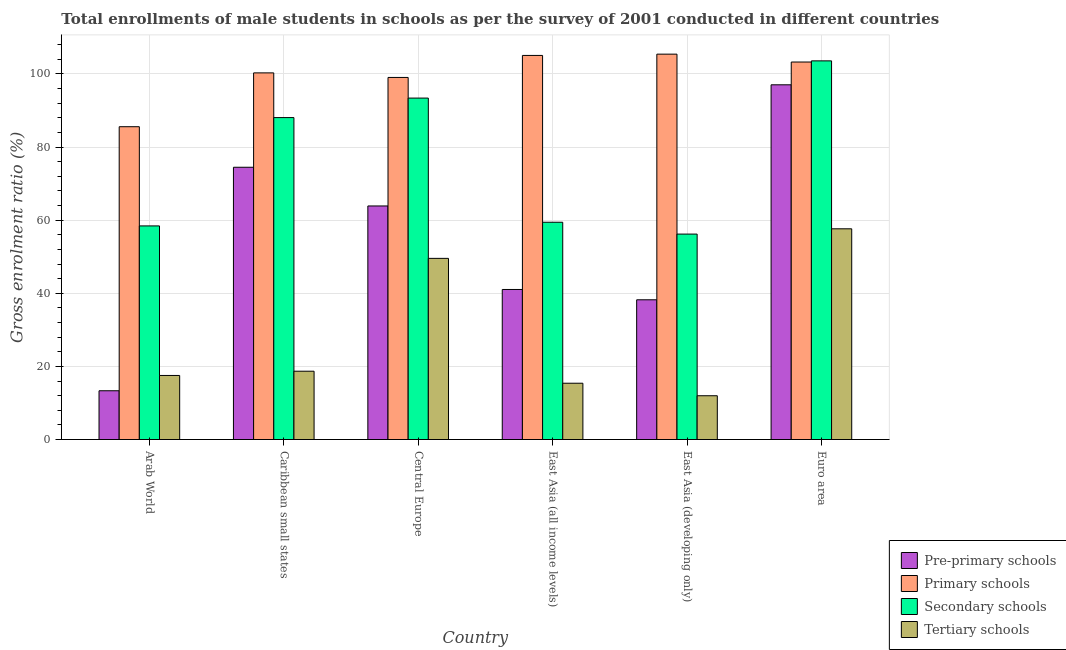How many groups of bars are there?
Offer a terse response. 6. Are the number of bars per tick equal to the number of legend labels?
Make the answer very short. Yes. Are the number of bars on each tick of the X-axis equal?
Provide a short and direct response. Yes. How many bars are there on the 5th tick from the left?
Give a very brief answer. 4. What is the label of the 1st group of bars from the left?
Make the answer very short. Arab World. In how many cases, is the number of bars for a given country not equal to the number of legend labels?
Offer a terse response. 0. What is the gross enrolment ratio(male) in tertiary schools in Caribbean small states?
Keep it short and to the point. 18.68. Across all countries, what is the maximum gross enrolment ratio(male) in secondary schools?
Make the answer very short. 103.56. Across all countries, what is the minimum gross enrolment ratio(male) in pre-primary schools?
Offer a very short reply. 13.34. In which country was the gross enrolment ratio(male) in pre-primary schools minimum?
Offer a terse response. Arab World. What is the total gross enrolment ratio(male) in primary schools in the graph?
Provide a succinct answer. 598.53. What is the difference between the gross enrolment ratio(male) in tertiary schools in Caribbean small states and that in East Asia (developing only)?
Ensure brevity in your answer.  6.71. What is the difference between the gross enrolment ratio(male) in secondary schools in Arab World and the gross enrolment ratio(male) in primary schools in Caribbean small states?
Keep it short and to the point. -41.85. What is the average gross enrolment ratio(male) in pre-primary schools per country?
Your answer should be compact. 54.65. What is the difference between the gross enrolment ratio(male) in secondary schools and gross enrolment ratio(male) in pre-primary schools in East Asia (all income levels)?
Offer a terse response. 18.39. In how many countries, is the gross enrolment ratio(male) in pre-primary schools greater than 76 %?
Provide a succinct answer. 1. What is the ratio of the gross enrolment ratio(male) in tertiary schools in Caribbean small states to that in East Asia (all income levels)?
Keep it short and to the point. 1.21. Is the difference between the gross enrolment ratio(male) in pre-primary schools in Central Europe and East Asia (all income levels) greater than the difference between the gross enrolment ratio(male) in secondary schools in Central Europe and East Asia (all income levels)?
Make the answer very short. No. What is the difference between the highest and the second highest gross enrolment ratio(male) in primary schools?
Provide a short and direct response. 0.35. What is the difference between the highest and the lowest gross enrolment ratio(male) in secondary schools?
Offer a very short reply. 47.37. Is the sum of the gross enrolment ratio(male) in pre-primary schools in Arab World and East Asia (all income levels) greater than the maximum gross enrolment ratio(male) in tertiary schools across all countries?
Your response must be concise. No. Is it the case that in every country, the sum of the gross enrolment ratio(male) in secondary schools and gross enrolment ratio(male) in tertiary schools is greater than the sum of gross enrolment ratio(male) in pre-primary schools and gross enrolment ratio(male) in primary schools?
Offer a terse response. No. What does the 2nd bar from the left in Arab World represents?
Ensure brevity in your answer.  Primary schools. What does the 3rd bar from the right in East Asia (all income levels) represents?
Your answer should be very brief. Primary schools. How many bars are there?
Ensure brevity in your answer.  24. What is the difference between two consecutive major ticks on the Y-axis?
Your answer should be very brief. 20. Does the graph contain any zero values?
Offer a very short reply. No. Does the graph contain grids?
Provide a succinct answer. Yes. What is the title of the graph?
Offer a terse response. Total enrollments of male students in schools as per the survey of 2001 conducted in different countries. Does "Methodology assessment" appear as one of the legend labels in the graph?
Offer a terse response. No. What is the Gross enrolment ratio (%) in Pre-primary schools in Arab World?
Provide a succinct answer. 13.34. What is the Gross enrolment ratio (%) in Primary schools in Arab World?
Provide a succinct answer. 85.55. What is the Gross enrolment ratio (%) in Secondary schools in Arab World?
Make the answer very short. 58.42. What is the Gross enrolment ratio (%) of Tertiary schools in Arab World?
Your response must be concise. 17.52. What is the Gross enrolment ratio (%) of Pre-primary schools in Caribbean small states?
Your answer should be compact. 74.46. What is the Gross enrolment ratio (%) of Primary schools in Caribbean small states?
Offer a terse response. 100.27. What is the Gross enrolment ratio (%) in Secondary schools in Caribbean small states?
Your answer should be compact. 88.05. What is the Gross enrolment ratio (%) in Tertiary schools in Caribbean small states?
Provide a short and direct response. 18.68. What is the Gross enrolment ratio (%) in Pre-primary schools in Central Europe?
Your answer should be very brief. 63.88. What is the Gross enrolment ratio (%) of Primary schools in Central Europe?
Keep it short and to the point. 99.02. What is the Gross enrolment ratio (%) in Secondary schools in Central Europe?
Provide a short and direct response. 93.38. What is the Gross enrolment ratio (%) of Tertiary schools in Central Europe?
Offer a very short reply. 49.54. What is the Gross enrolment ratio (%) in Pre-primary schools in East Asia (all income levels)?
Your response must be concise. 41.03. What is the Gross enrolment ratio (%) in Primary schools in East Asia (all income levels)?
Your response must be concise. 105.04. What is the Gross enrolment ratio (%) in Secondary schools in East Asia (all income levels)?
Your answer should be very brief. 59.42. What is the Gross enrolment ratio (%) in Tertiary schools in East Asia (all income levels)?
Provide a short and direct response. 15.4. What is the Gross enrolment ratio (%) in Pre-primary schools in East Asia (developing only)?
Your answer should be very brief. 38.21. What is the Gross enrolment ratio (%) in Primary schools in East Asia (developing only)?
Offer a terse response. 105.4. What is the Gross enrolment ratio (%) of Secondary schools in East Asia (developing only)?
Your answer should be compact. 56.19. What is the Gross enrolment ratio (%) of Tertiary schools in East Asia (developing only)?
Provide a succinct answer. 11.97. What is the Gross enrolment ratio (%) of Pre-primary schools in Euro area?
Your answer should be very brief. 97.01. What is the Gross enrolment ratio (%) in Primary schools in Euro area?
Provide a short and direct response. 103.24. What is the Gross enrolment ratio (%) of Secondary schools in Euro area?
Your response must be concise. 103.56. What is the Gross enrolment ratio (%) in Tertiary schools in Euro area?
Offer a terse response. 57.63. Across all countries, what is the maximum Gross enrolment ratio (%) in Pre-primary schools?
Give a very brief answer. 97.01. Across all countries, what is the maximum Gross enrolment ratio (%) of Primary schools?
Make the answer very short. 105.4. Across all countries, what is the maximum Gross enrolment ratio (%) of Secondary schools?
Your answer should be compact. 103.56. Across all countries, what is the maximum Gross enrolment ratio (%) of Tertiary schools?
Your answer should be compact. 57.63. Across all countries, what is the minimum Gross enrolment ratio (%) of Pre-primary schools?
Keep it short and to the point. 13.34. Across all countries, what is the minimum Gross enrolment ratio (%) of Primary schools?
Your answer should be very brief. 85.55. Across all countries, what is the minimum Gross enrolment ratio (%) of Secondary schools?
Your response must be concise. 56.19. Across all countries, what is the minimum Gross enrolment ratio (%) of Tertiary schools?
Provide a succinct answer. 11.97. What is the total Gross enrolment ratio (%) in Pre-primary schools in the graph?
Offer a terse response. 327.93. What is the total Gross enrolment ratio (%) in Primary schools in the graph?
Keep it short and to the point. 598.53. What is the total Gross enrolment ratio (%) of Secondary schools in the graph?
Your answer should be very brief. 459.01. What is the total Gross enrolment ratio (%) in Tertiary schools in the graph?
Your answer should be compact. 170.75. What is the difference between the Gross enrolment ratio (%) in Pre-primary schools in Arab World and that in Caribbean small states?
Ensure brevity in your answer.  -61.12. What is the difference between the Gross enrolment ratio (%) of Primary schools in Arab World and that in Caribbean small states?
Give a very brief answer. -14.72. What is the difference between the Gross enrolment ratio (%) in Secondary schools in Arab World and that in Caribbean small states?
Provide a short and direct response. -29.63. What is the difference between the Gross enrolment ratio (%) in Tertiary schools in Arab World and that in Caribbean small states?
Your answer should be compact. -1.16. What is the difference between the Gross enrolment ratio (%) in Pre-primary schools in Arab World and that in Central Europe?
Ensure brevity in your answer.  -50.54. What is the difference between the Gross enrolment ratio (%) of Primary schools in Arab World and that in Central Europe?
Your answer should be compact. -13.47. What is the difference between the Gross enrolment ratio (%) of Secondary schools in Arab World and that in Central Europe?
Offer a very short reply. -34.96. What is the difference between the Gross enrolment ratio (%) of Tertiary schools in Arab World and that in Central Europe?
Give a very brief answer. -32.02. What is the difference between the Gross enrolment ratio (%) of Pre-primary schools in Arab World and that in East Asia (all income levels)?
Your answer should be very brief. -27.7. What is the difference between the Gross enrolment ratio (%) in Primary schools in Arab World and that in East Asia (all income levels)?
Offer a terse response. -19.49. What is the difference between the Gross enrolment ratio (%) of Secondary schools in Arab World and that in East Asia (all income levels)?
Keep it short and to the point. -1. What is the difference between the Gross enrolment ratio (%) of Tertiary schools in Arab World and that in East Asia (all income levels)?
Provide a short and direct response. 2.12. What is the difference between the Gross enrolment ratio (%) of Pre-primary schools in Arab World and that in East Asia (developing only)?
Your answer should be compact. -24.88. What is the difference between the Gross enrolment ratio (%) of Primary schools in Arab World and that in East Asia (developing only)?
Ensure brevity in your answer.  -19.84. What is the difference between the Gross enrolment ratio (%) of Secondary schools in Arab World and that in East Asia (developing only)?
Give a very brief answer. 2.23. What is the difference between the Gross enrolment ratio (%) in Tertiary schools in Arab World and that in East Asia (developing only)?
Your answer should be very brief. 5.55. What is the difference between the Gross enrolment ratio (%) of Pre-primary schools in Arab World and that in Euro area?
Your response must be concise. -83.67. What is the difference between the Gross enrolment ratio (%) in Primary schools in Arab World and that in Euro area?
Your response must be concise. -17.69. What is the difference between the Gross enrolment ratio (%) in Secondary schools in Arab World and that in Euro area?
Provide a succinct answer. -45.14. What is the difference between the Gross enrolment ratio (%) of Tertiary schools in Arab World and that in Euro area?
Your answer should be compact. -40.11. What is the difference between the Gross enrolment ratio (%) in Pre-primary schools in Caribbean small states and that in Central Europe?
Offer a terse response. 10.58. What is the difference between the Gross enrolment ratio (%) in Primary schools in Caribbean small states and that in Central Europe?
Offer a very short reply. 1.25. What is the difference between the Gross enrolment ratio (%) of Secondary schools in Caribbean small states and that in Central Europe?
Give a very brief answer. -5.33. What is the difference between the Gross enrolment ratio (%) in Tertiary schools in Caribbean small states and that in Central Europe?
Make the answer very short. -30.86. What is the difference between the Gross enrolment ratio (%) of Pre-primary schools in Caribbean small states and that in East Asia (all income levels)?
Your response must be concise. 33.43. What is the difference between the Gross enrolment ratio (%) in Primary schools in Caribbean small states and that in East Asia (all income levels)?
Your answer should be compact. -4.77. What is the difference between the Gross enrolment ratio (%) in Secondary schools in Caribbean small states and that in East Asia (all income levels)?
Provide a short and direct response. 28.62. What is the difference between the Gross enrolment ratio (%) of Tertiary schools in Caribbean small states and that in East Asia (all income levels)?
Offer a very short reply. 3.29. What is the difference between the Gross enrolment ratio (%) of Pre-primary schools in Caribbean small states and that in East Asia (developing only)?
Your answer should be very brief. 36.24. What is the difference between the Gross enrolment ratio (%) in Primary schools in Caribbean small states and that in East Asia (developing only)?
Provide a short and direct response. -5.12. What is the difference between the Gross enrolment ratio (%) in Secondary schools in Caribbean small states and that in East Asia (developing only)?
Give a very brief answer. 31.86. What is the difference between the Gross enrolment ratio (%) in Tertiary schools in Caribbean small states and that in East Asia (developing only)?
Ensure brevity in your answer.  6.71. What is the difference between the Gross enrolment ratio (%) of Pre-primary schools in Caribbean small states and that in Euro area?
Provide a succinct answer. -22.55. What is the difference between the Gross enrolment ratio (%) of Primary schools in Caribbean small states and that in Euro area?
Your answer should be very brief. -2.97. What is the difference between the Gross enrolment ratio (%) of Secondary schools in Caribbean small states and that in Euro area?
Ensure brevity in your answer.  -15.51. What is the difference between the Gross enrolment ratio (%) in Tertiary schools in Caribbean small states and that in Euro area?
Offer a terse response. -38.95. What is the difference between the Gross enrolment ratio (%) in Pre-primary schools in Central Europe and that in East Asia (all income levels)?
Offer a terse response. 22.84. What is the difference between the Gross enrolment ratio (%) in Primary schools in Central Europe and that in East Asia (all income levels)?
Give a very brief answer. -6.02. What is the difference between the Gross enrolment ratio (%) in Secondary schools in Central Europe and that in East Asia (all income levels)?
Offer a terse response. 33.96. What is the difference between the Gross enrolment ratio (%) of Tertiary schools in Central Europe and that in East Asia (all income levels)?
Give a very brief answer. 34.15. What is the difference between the Gross enrolment ratio (%) in Pre-primary schools in Central Europe and that in East Asia (developing only)?
Give a very brief answer. 25.66. What is the difference between the Gross enrolment ratio (%) in Primary schools in Central Europe and that in East Asia (developing only)?
Provide a succinct answer. -6.37. What is the difference between the Gross enrolment ratio (%) in Secondary schools in Central Europe and that in East Asia (developing only)?
Your answer should be compact. 37.19. What is the difference between the Gross enrolment ratio (%) in Tertiary schools in Central Europe and that in East Asia (developing only)?
Keep it short and to the point. 37.57. What is the difference between the Gross enrolment ratio (%) in Pre-primary schools in Central Europe and that in Euro area?
Offer a very short reply. -33.14. What is the difference between the Gross enrolment ratio (%) in Primary schools in Central Europe and that in Euro area?
Your response must be concise. -4.22. What is the difference between the Gross enrolment ratio (%) in Secondary schools in Central Europe and that in Euro area?
Provide a short and direct response. -10.18. What is the difference between the Gross enrolment ratio (%) in Tertiary schools in Central Europe and that in Euro area?
Your response must be concise. -8.09. What is the difference between the Gross enrolment ratio (%) of Pre-primary schools in East Asia (all income levels) and that in East Asia (developing only)?
Provide a succinct answer. 2.82. What is the difference between the Gross enrolment ratio (%) in Primary schools in East Asia (all income levels) and that in East Asia (developing only)?
Your answer should be compact. -0.35. What is the difference between the Gross enrolment ratio (%) of Secondary schools in East Asia (all income levels) and that in East Asia (developing only)?
Make the answer very short. 3.24. What is the difference between the Gross enrolment ratio (%) in Tertiary schools in East Asia (all income levels) and that in East Asia (developing only)?
Your response must be concise. 3.43. What is the difference between the Gross enrolment ratio (%) of Pre-primary schools in East Asia (all income levels) and that in Euro area?
Offer a terse response. -55.98. What is the difference between the Gross enrolment ratio (%) of Primary schools in East Asia (all income levels) and that in Euro area?
Give a very brief answer. 1.8. What is the difference between the Gross enrolment ratio (%) in Secondary schools in East Asia (all income levels) and that in Euro area?
Keep it short and to the point. -44.13. What is the difference between the Gross enrolment ratio (%) in Tertiary schools in East Asia (all income levels) and that in Euro area?
Make the answer very short. -42.23. What is the difference between the Gross enrolment ratio (%) of Pre-primary schools in East Asia (developing only) and that in Euro area?
Your answer should be compact. -58.8. What is the difference between the Gross enrolment ratio (%) in Primary schools in East Asia (developing only) and that in Euro area?
Your response must be concise. 2.16. What is the difference between the Gross enrolment ratio (%) in Secondary schools in East Asia (developing only) and that in Euro area?
Offer a very short reply. -47.37. What is the difference between the Gross enrolment ratio (%) of Tertiary schools in East Asia (developing only) and that in Euro area?
Your response must be concise. -45.66. What is the difference between the Gross enrolment ratio (%) of Pre-primary schools in Arab World and the Gross enrolment ratio (%) of Primary schools in Caribbean small states?
Make the answer very short. -86.94. What is the difference between the Gross enrolment ratio (%) of Pre-primary schools in Arab World and the Gross enrolment ratio (%) of Secondary schools in Caribbean small states?
Offer a very short reply. -74.71. What is the difference between the Gross enrolment ratio (%) of Pre-primary schools in Arab World and the Gross enrolment ratio (%) of Tertiary schools in Caribbean small states?
Provide a succinct answer. -5.35. What is the difference between the Gross enrolment ratio (%) of Primary schools in Arab World and the Gross enrolment ratio (%) of Secondary schools in Caribbean small states?
Offer a very short reply. -2.49. What is the difference between the Gross enrolment ratio (%) in Primary schools in Arab World and the Gross enrolment ratio (%) in Tertiary schools in Caribbean small states?
Give a very brief answer. 66.87. What is the difference between the Gross enrolment ratio (%) of Secondary schools in Arab World and the Gross enrolment ratio (%) of Tertiary schools in Caribbean small states?
Keep it short and to the point. 39.74. What is the difference between the Gross enrolment ratio (%) of Pre-primary schools in Arab World and the Gross enrolment ratio (%) of Primary schools in Central Europe?
Your answer should be compact. -85.69. What is the difference between the Gross enrolment ratio (%) in Pre-primary schools in Arab World and the Gross enrolment ratio (%) in Secondary schools in Central Europe?
Provide a short and direct response. -80.04. What is the difference between the Gross enrolment ratio (%) of Pre-primary schools in Arab World and the Gross enrolment ratio (%) of Tertiary schools in Central Europe?
Your answer should be very brief. -36.21. What is the difference between the Gross enrolment ratio (%) in Primary schools in Arab World and the Gross enrolment ratio (%) in Secondary schools in Central Europe?
Ensure brevity in your answer.  -7.83. What is the difference between the Gross enrolment ratio (%) in Primary schools in Arab World and the Gross enrolment ratio (%) in Tertiary schools in Central Europe?
Keep it short and to the point. 36.01. What is the difference between the Gross enrolment ratio (%) in Secondary schools in Arab World and the Gross enrolment ratio (%) in Tertiary schools in Central Europe?
Your answer should be compact. 8.87. What is the difference between the Gross enrolment ratio (%) in Pre-primary schools in Arab World and the Gross enrolment ratio (%) in Primary schools in East Asia (all income levels)?
Ensure brevity in your answer.  -91.71. What is the difference between the Gross enrolment ratio (%) in Pre-primary schools in Arab World and the Gross enrolment ratio (%) in Secondary schools in East Asia (all income levels)?
Your response must be concise. -46.09. What is the difference between the Gross enrolment ratio (%) of Pre-primary schools in Arab World and the Gross enrolment ratio (%) of Tertiary schools in East Asia (all income levels)?
Provide a succinct answer. -2.06. What is the difference between the Gross enrolment ratio (%) of Primary schools in Arab World and the Gross enrolment ratio (%) of Secondary schools in East Asia (all income levels)?
Offer a terse response. 26.13. What is the difference between the Gross enrolment ratio (%) of Primary schools in Arab World and the Gross enrolment ratio (%) of Tertiary schools in East Asia (all income levels)?
Give a very brief answer. 70.15. What is the difference between the Gross enrolment ratio (%) in Secondary schools in Arab World and the Gross enrolment ratio (%) in Tertiary schools in East Asia (all income levels)?
Your answer should be compact. 43.02. What is the difference between the Gross enrolment ratio (%) of Pre-primary schools in Arab World and the Gross enrolment ratio (%) of Primary schools in East Asia (developing only)?
Your answer should be very brief. -92.06. What is the difference between the Gross enrolment ratio (%) of Pre-primary schools in Arab World and the Gross enrolment ratio (%) of Secondary schools in East Asia (developing only)?
Make the answer very short. -42.85. What is the difference between the Gross enrolment ratio (%) of Pre-primary schools in Arab World and the Gross enrolment ratio (%) of Tertiary schools in East Asia (developing only)?
Make the answer very short. 1.36. What is the difference between the Gross enrolment ratio (%) in Primary schools in Arab World and the Gross enrolment ratio (%) in Secondary schools in East Asia (developing only)?
Ensure brevity in your answer.  29.37. What is the difference between the Gross enrolment ratio (%) of Primary schools in Arab World and the Gross enrolment ratio (%) of Tertiary schools in East Asia (developing only)?
Offer a terse response. 73.58. What is the difference between the Gross enrolment ratio (%) of Secondary schools in Arab World and the Gross enrolment ratio (%) of Tertiary schools in East Asia (developing only)?
Offer a very short reply. 46.45. What is the difference between the Gross enrolment ratio (%) of Pre-primary schools in Arab World and the Gross enrolment ratio (%) of Primary schools in Euro area?
Provide a short and direct response. -89.9. What is the difference between the Gross enrolment ratio (%) of Pre-primary schools in Arab World and the Gross enrolment ratio (%) of Secondary schools in Euro area?
Make the answer very short. -90.22. What is the difference between the Gross enrolment ratio (%) in Pre-primary schools in Arab World and the Gross enrolment ratio (%) in Tertiary schools in Euro area?
Give a very brief answer. -44.29. What is the difference between the Gross enrolment ratio (%) in Primary schools in Arab World and the Gross enrolment ratio (%) in Secondary schools in Euro area?
Keep it short and to the point. -18. What is the difference between the Gross enrolment ratio (%) of Primary schools in Arab World and the Gross enrolment ratio (%) of Tertiary schools in Euro area?
Give a very brief answer. 27.92. What is the difference between the Gross enrolment ratio (%) of Secondary schools in Arab World and the Gross enrolment ratio (%) of Tertiary schools in Euro area?
Your response must be concise. 0.79. What is the difference between the Gross enrolment ratio (%) of Pre-primary schools in Caribbean small states and the Gross enrolment ratio (%) of Primary schools in Central Europe?
Your response must be concise. -24.57. What is the difference between the Gross enrolment ratio (%) of Pre-primary schools in Caribbean small states and the Gross enrolment ratio (%) of Secondary schools in Central Europe?
Your answer should be compact. -18.92. What is the difference between the Gross enrolment ratio (%) in Pre-primary schools in Caribbean small states and the Gross enrolment ratio (%) in Tertiary schools in Central Europe?
Ensure brevity in your answer.  24.91. What is the difference between the Gross enrolment ratio (%) of Primary schools in Caribbean small states and the Gross enrolment ratio (%) of Secondary schools in Central Europe?
Provide a short and direct response. 6.89. What is the difference between the Gross enrolment ratio (%) of Primary schools in Caribbean small states and the Gross enrolment ratio (%) of Tertiary schools in Central Europe?
Make the answer very short. 50.73. What is the difference between the Gross enrolment ratio (%) of Secondary schools in Caribbean small states and the Gross enrolment ratio (%) of Tertiary schools in Central Europe?
Offer a terse response. 38.5. What is the difference between the Gross enrolment ratio (%) in Pre-primary schools in Caribbean small states and the Gross enrolment ratio (%) in Primary schools in East Asia (all income levels)?
Offer a very short reply. -30.58. What is the difference between the Gross enrolment ratio (%) of Pre-primary schools in Caribbean small states and the Gross enrolment ratio (%) of Secondary schools in East Asia (all income levels)?
Provide a short and direct response. 15.04. What is the difference between the Gross enrolment ratio (%) of Pre-primary schools in Caribbean small states and the Gross enrolment ratio (%) of Tertiary schools in East Asia (all income levels)?
Provide a succinct answer. 59.06. What is the difference between the Gross enrolment ratio (%) in Primary schools in Caribbean small states and the Gross enrolment ratio (%) in Secondary schools in East Asia (all income levels)?
Provide a succinct answer. 40.85. What is the difference between the Gross enrolment ratio (%) in Primary schools in Caribbean small states and the Gross enrolment ratio (%) in Tertiary schools in East Asia (all income levels)?
Your response must be concise. 84.87. What is the difference between the Gross enrolment ratio (%) in Secondary schools in Caribbean small states and the Gross enrolment ratio (%) in Tertiary schools in East Asia (all income levels)?
Ensure brevity in your answer.  72.65. What is the difference between the Gross enrolment ratio (%) of Pre-primary schools in Caribbean small states and the Gross enrolment ratio (%) of Primary schools in East Asia (developing only)?
Your answer should be very brief. -30.94. What is the difference between the Gross enrolment ratio (%) of Pre-primary schools in Caribbean small states and the Gross enrolment ratio (%) of Secondary schools in East Asia (developing only)?
Offer a terse response. 18.27. What is the difference between the Gross enrolment ratio (%) of Pre-primary schools in Caribbean small states and the Gross enrolment ratio (%) of Tertiary schools in East Asia (developing only)?
Your response must be concise. 62.49. What is the difference between the Gross enrolment ratio (%) of Primary schools in Caribbean small states and the Gross enrolment ratio (%) of Secondary schools in East Asia (developing only)?
Ensure brevity in your answer.  44.09. What is the difference between the Gross enrolment ratio (%) of Primary schools in Caribbean small states and the Gross enrolment ratio (%) of Tertiary schools in East Asia (developing only)?
Offer a terse response. 88.3. What is the difference between the Gross enrolment ratio (%) of Secondary schools in Caribbean small states and the Gross enrolment ratio (%) of Tertiary schools in East Asia (developing only)?
Keep it short and to the point. 76.07. What is the difference between the Gross enrolment ratio (%) in Pre-primary schools in Caribbean small states and the Gross enrolment ratio (%) in Primary schools in Euro area?
Your answer should be compact. -28.78. What is the difference between the Gross enrolment ratio (%) of Pre-primary schools in Caribbean small states and the Gross enrolment ratio (%) of Secondary schools in Euro area?
Keep it short and to the point. -29.1. What is the difference between the Gross enrolment ratio (%) of Pre-primary schools in Caribbean small states and the Gross enrolment ratio (%) of Tertiary schools in Euro area?
Give a very brief answer. 16.83. What is the difference between the Gross enrolment ratio (%) in Primary schools in Caribbean small states and the Gross enrolment ratio (%) in Secondary schools in Euro area?
Make the answer very short. -3.28. What is the difference between the Gross enrolment ratio (%) of Primary schools in Caribbean small states and the Gross enrolment ratio (%) of Tertiary schools in Euro area?
Your answer should be very brief. 42.64. What is the difference between the Gross enrolment ratio (%) in Secondary schools in Caribbean small states and the Gross enrolment ratio (%) in Tertiary schools in Euro area?
Your answer should be compact. 30.42. What is the difference between the Gross enrolment ratio (%) in Pre-primary schools in Central Europe and the Gross enrolment ratio (%) in Primary schools in East Asia (all income levels)?
Provide a succinct answer. -41.17. What is the difference between the Gross enrolment ratio (%) of Pre-primary schools in Central Europe and the Gross enrolment ratio (%) of Secondary schools in East Asia (all income levels)?
Make the answer very short. 4.45. What is the difference between the Gross enrolment ratio (%) of Pre-primary schools in Central Europe and the Gross enrolment ratio (%) of Tertiary schools in East Asia (all income levels)?
Ensure brevity in your answer.  48.48. What is the difference between the Gross enrolment ratio (%) in Primary schools in Central Europe and the Gross enrolment ratio (%) in Secondary schools in East Asia (all income levels)?
Ensure brevity in your answer.  39.6. What is the difference between the Gross enrolment ratio (%) of Primary schools in Central Europe and the Gross enrolment ratio (%) of Tertiary schools in East Asia (all income levels)?
Make the answer very short. 83.63. What is the difference between the Gross enrolment ratio (%) of Secondary schools in Central Europe and the Gross enrolment ratio (%) of Tertiary schools in East Asia (all income levels)?
Make the answer very short. 77.98. What is the difference between the Gross enrolment ratio (%) of Pre-primary schools in Central Europe and the Gross enrolment ratio (%) of Primary schools in East Asia (developing only)?
Offer a very short reply. -41.52. What is the difference between the Gross enrolment ratio (%) in Pre-primary schools in Central Europe and the Gross enrolment ratio (%) in Secondary schools in East Asia (developing only)?
Your answer should be compact. 7.69. What is the difference between the Gross enrolment ratio (%) of Pre-primary schools in Central Europe and the Gross enrolment ratio (%) of Tertiary schools in East Asia (developing only)?
Ensure brevity in your answer.  51.9. What is the difference between the Gross enrolment ratio (%) in Primary schools in Central Europe and the Gross enrolment ratio (%) in Secondary schools in East Asia (developing only)?
Make the answer very short. 42.84. What is the difference between the Gross enrolment ratio (%) in Primary schools in Central Europe and the Gross enrolment ratio (%) in Tertiary schools in East Asia (developing only)?
Your answer should be very brief. 87.05. What is the difference between the Gross enrolment ratio (%) in Secondary schools in Central Europe and the Gross enrolment ratio (%) in Tertiary schools in East Asia (developing only)?
Offer a terse response. 81.41. What is the difference between the Gross enrolment ratio (%) of Pre-primary schools in Central Europe and the Gross enrolment ratio (%) of Primary schools in Euro area?
Provide a short and direct response. -39.37. What is the difference between the Gross enrolment ratio (%) of Pre-primary schools in Central Europe and the Gross enrolment ratio (%) of Secondary schools in Euro area?
Offer a very short reply. -39.68. What is the difference between the Gross enrolment ratio (%) in Pre-primary schools in Central Europe and the Gross enrolment ratio (%) in Tertiary schools in Euro area?
Ensure brevity in your answer.  6.24. What is the difference between the Gross enrolment ratio (%) in Primary schools in Central Europe and the Gross enrolment ratio (%) in Secondary schools in Euro area?
Provide a succinct answer. -4.53. What is the difference between the Gross enrolment ratio (%) in Primary schools in Central Europe and the Gross enrolment ratio (%) in Tertiary schools in Euro area?
Make the answer very short. 41.39. What is the difference between the Gross enrolment ratio (%) in Secondary schools in Central Europe and the Gross enrolment ratio (%) in Tertiary schools in Euro area?
Make the answer very short. 35.75. What is the difference between the Gross enrolment ratio (%) of Pre-primary schools in East Asia (all income levels) and the Gross enrolment ratio (%) of Primary schools in East Asia (developing only)?
Keep it short and to the point. -64.36. What is the difference between the Gross enrolment ratio (%) of Pre-primary schools in East Asia (all income levels) and the Gross enrolment ratio (%) of Secondary schools in East Asia (developing only)?
Keep it short and to the point. -15.15. What is the difference between the Gross enrolment ratio (%) in Pre-primary schools in East Asia (all income levels) and the Gross enrolment ratio (%) in Tertiary schools in East Asia (developing only)?
Provide a succinct answer. 29.06. What is the difference between the Gross enrolment ratio (%) in Primary schools in East Asia (all income levels) and the Gross enrolment ratio (%) in Secondary schools in East Asia (developing only)?
Keep it short and to the point. 48.86. What is the difference between the Gross enrolment ratio (%) of Primary schools in East Asia (all income levels) and the Gross enrolment ratio (%) of Tertiary schools in East Asia (developing only)?
Give a very brief answer. 93.07. What is the difference between the Gross enrolment ratio (%) of Secondary schools in East Asia (all income levels) and the Gross enrolment ratio (%) of Tertiary schools in East Asia (developing only)?
Keep it short and to the point. 47.45. What is the difference between the Gross enrolment ratio (%) in Pre-primary schools in East Asia (all income levels) and the Gross enrolment ratio (%) in Primary schools in Euro area?
Provide a succinct answer. -62.21. What is the difference between the Gross enrolment ratio (%) of Pre-primary schools in East Asia (all income levels) and the Gross enrolment ratio (%) of Secondary schools in Euro area?
Offer a terse response. -62.52. What is the difference between the Gross enrolment ratio (%) of Pre-primary schools in East Asia (all income levels) and the Gross enrolment ratio (%) of Tertiary schools in Euro area?
Your response must be concise. -16.6. What is the difference between the Gross enrolment ratio (%) of Primary schools in East Asia (all income levels) and the Gross enrolment ratio (%) of Secondary schools in Euro area?
Make the answer very short. 1.49. What is the difference between the Gross enrolment ratio (%) of Primary schools in East Asia (all income levels) and the Gross enrolment ratio (%) of Tertiary schools in Euro area?
Your answer should be very brief. 47.41. What is the difference between the Gross enrolment ratio (%) of Secondary schools in East Asia (all income levels) and the Gross enrolment ratio (%) of Tertiary schools in Euro area?
Provide a short and direct response. 1.79. What is the difference between the Gross enrolment ratio (%) in Pre-primary schools in East Asia (developing only) and the Gross enrolment ratio (%) in Primary schools in Euro area?
Offer a very short reply. -65.03. What is the difference between the Gross enrolment ratio (%) in Pre-primary schools in East Asia (developing only) and the Gross enrolment ratio (%) in Secondary schools in Euro area?
Make the answer very short. -65.34. What is the difference between the Gross enrolment ratio (%) in Pre-primary schools in East Asia (developing only) and the Gross enrolment ratio (%) in Tertiary schools in Euro area?
Your answer should be compact. -19.42. What is the difference between the Gross enrolment ratio (%) of Primary schools in East Asia (developing only) and the Gross enrolment ratio (%) of Secondary schools in Euro area?
Provide a short and direct response. 1.84. What is the difference between the Gross enrolment ratio (%) of Primary schools in East Asia (developing only) and the Gross enrolment ratio (%) of Tertiary schools in Euro area?
Provide a short and direct response. 47.77. What is the difference between the Gross enrolment ratio (%) in Secondary schools in East Asia (developing only) and the Gross enrolment ratio (%) in Tertiary schools in Euro area?
Give a very brief answer. -1.44. What is the average Gross enrolment ratio (%) of Pre-primary schools per country?
Give a very brief answer. 54.65. What is the average Gross enrolment ratio (%) in Primary schools per country?
Provide a short and direct response. 99.75. What is the average Gross enrolment ratio (%) in Secondary schools per country?
Ensure brevity in your answer.  76.5. What is the average Gross enrolment ratio (%) in Tertiary schools per country?
Ensure brevity in your answer.  28.46. What is the difference between the Gross enrolment ratio (%) in Pre-primary schools and Gross enrolment ratio (%) in Primary schools in Arab World?
Your response must be concise. -72.22. What is the difference between the Gross enrolment ratio (%) in Pre-primary schools and Gross enrolment ratio (%) in Secondary schools in Arab World?
Your answer should be very brief. -45.08. What is the difference between the Gross enrolment ratio (%) in Pre-primary schools and Gross enrolment ratio (%) in Tertiary schools in Arab World?
Your answer should be compact. -4.18. What is the difference between the Gross enrolment ratio (%) of Primary schools and Gross enrolment ratio (%) of Secondary schools in Arab World?
Keep it short and to the point. 27.13. What is the difference between the Gross enrolment ratio (%) of Primary schools and Gross enrolment ratio (%) of Tertiary schools in Arab World?
Provide a succinct answer. 68.03. What is the difference between the Gross enrolment ratio (%) of Secondary schools and Gross enrolment ratio (%) of Tertiary schools in Arab World?
Offer a terse response. 40.9. What is the difference between the Gross enrolment ratio (%) of Pre-primary schools and Gross enrolment ratio (%) of Primary schools in Caribbean small states?
Make the answer very short. -25.81. What is the difference between the Gross enrolment ratio (%) in Pre-primary schools and Gross enrolment ratio (%) in Secondary schools in Caribbean small states?
Provide a short and direct response. -13.59. What is the difference between the Gross enrolment ratio (%) of Pre-primary schools and Gross enrolment ratio (%) of Tertiary schools in Caribbean small states?
Offer a terse response. 55.78. What is the difference between the Gross enrolment ratio (%) in Primary schools and Gross enrolment ratio (%) in Secondary schools in Caribbean small states?
Offer a very short reply. 12.23. What is the difference between the Gross enrolment ratio (%) of Primary schools and Gross enrolment ratio (%) of Tertiary schools in Caribbean small states?
Your answer should be compact. 81.59. What is the difference between the Gross enrolment ratio (%) of Secondary schools and Gross enrolment ratio (%) of Tertiary schools in Caribbean small states?
Give a very brief answer. 69.36. What is the difference between the Gross enrolment ratio (%) in Pre-primary schools and Gross enrolment ratio (%) in Primary schools in Central Europe?
Your answer should be compact. -35.15. What is the difference between the Gross enrolment ratio (%) in Pre-primary schools and Gross enrolment ratio (%) in Secondary schools in Central Europe?
Make the answer very short. -29.5. What is the difference between the Gross enrolment ratio (%) in Pre-primary schools and Gross enrolment ratio (%) in Tertiary schools in Central Europe?
Make the answer very short. 14.33. What is the difference between the Gross enrolment ratio (%) in Primary schools and Gross enrolment ratio (%) in Secondary schools in Central Europe?
Your response must be concise. 5.65. What is the difference between the Gross enrolment ratio (%) of Primary schools and Gross enrolment ratio (%) of Tertiary schools in Central Europe?
Your response must be concise. 49.48. What is the difference between the Gross enrolment ratio (%) of Secondary schools and Gross enrolment ratio (%) of Tertiary schools in Central Europe?
Your answer should be very brief. 43.83. What is the difference between the Gross enrolment ratio (%) of Pre-primary schools and Gross enrolment ratio (%) of Primary schools in East Asia (all income levels)?
Make the answer very short. -64.01. What is the difference between the Gross enrolment ratio (%) of Pre-primary schools and Gross enrolment ratio (%) of Secondary schools in East Asia (all income levels)?
Make the answer very short. -18.39. What is the difference between the Gross enrolment ratio (%) of Pre-primary schools and Gross enrolment ratio (%) of Tertiary schools in East Asia (all income levels)?
Ensure brevity in your answer.  25.64. What is the difference between the Gross enrolment ratio (%) of Primary schools and Gross enrolment ratio (%) of Secondary schools in East Asia (all income levels)?
Give a very brief answer. 45.62. What is the difference between the Gross enrolment ratio (%) of Primary schools and Gross enrolment ratio (%) of Tertiary schools in East Asia (all income levels)?
Offer a terse response. 89.65. What is the difference between the Gross enrolment ratio (%) of Secondary schools and Gross enrolment ratio (%) of Tertiary schools in East Asia (all income levels)?
Provide a short and direct response. 44.02. What is the difference between the Gross enrolment ratio (%) in Pre-primary schools and Gross enrolment ratio (%) in Primary schools in East Asia (developing only)?
Keep it short and to the point. -67.18. What is the difference between the Gross enrolment ratio (%) in Pre-primary schools and Gross enrolment ratio (%) in Secondary schools in East Asia (developing only)?
Your response must be concise. -17.97. What is the difference between the Gross enrolment ratio (%) in Pre-primary schools and Gross enrolment ratio (%) in Tertiary schools in East Asia (developing only)?
Make the answer very short. 26.24. What is the difference between the Gross enrolment ratio (%) in Primary schools and Gross enrolment ratio (%) in Secondary schools in East Asia (developing only)?
Your response must be concise. 49.21. What is the difference between the Gross enrolment ratio (%) of Primary schools and Gross enrolment ratio (%) of Tertiary schools in East Asia (developing only)?
Offer a terse response. 93.42. What is the difference between the Gross enrolment ratio (%) of Secondary schools and Gross enrolment ratio (%) of Tertiary schools in East Asia (developing only)?
Your answer should be very brief. 44.21. What is the difference between the Gross enrolment ratio (%) of Pre-primary schools and Gross enrolment ratio (%) of Primary schools in Euro area?
Make the answer very short. -6.23. What is the difference between the Gross enrolment ratio (%) of Pre-primary schools and Gross enrolment ratio (%) of Secondary schools in Euro area?
Ensure brevity in your answer.  -6.54. What is the difference between the Gross enrolment ratio (%) of Pre-primary schools and Gross enrolment ratio (%) of Tertiary schools in Euro area?
Make the answer very short. 39.38. What is the difference between the Gross enrolment ratio (%) of Primary schools and Gross enrolment ratio (%) of Secondary schools in Euro area?
Provide a succinct answer. -0.32. What is the difference between the Gross enrolment ratio (%) of Primary schools and Gross enrolment ratio (%) of Tertiary schools in Euro area?
Provide a succinct answer. 45.61. What is the difference between the Gross enrolment ratio (%) in Secondary schools and Gross enrolment ratio (%) in Tertiary schools in Euro area?
Your answer should be very brief. 45.93. What is the ratio of the Gross enrolment ratio (%) in Pre-primary schools in Arab World to that in Caribbean small states?
Your response must be concise. 0.18. What is the ratio of the Gross enrolment ratio (%) in Primary schools in Arab World to that in Caribbean small states?
Offer a terse response. 0.85. What is the ratio of the Gross enrolment ratio (%) of Secondary schools in Arab World to that in Caribbean small states?
Offer a terse response. 0.66. What is the ratio of the Gross enrolment ratio (%) in Tertiary schools in Arab World to that in Caribbean small states?
Make the answer very short. 0.94. What is the ratio of the Gross enrolment ratio (%) of Pre-primary schools in Arab World to that in Central Europe?
Your answer should be compact. 0.21. What is the ratio of the Gross enrolment ratio (%) in Primary schools in Arab World to that in Central Europe?
Offer a terse response. 0.86. What is the ratio of the Gross enrolment ratio (%) of Secondary schools in Arab World to that in Central Europe?
Provide a short and direct response. 0.63. What is the ratio of the Gross enrolment ratio (%) of Tertiary schools in Arab World to that in Central Europe?
Your answer should be compact. 0.35. What is the ratio of the Gross enrolment ratio (%) in Pre-primary schools in Arab World to that in East Asia (all income levels)?
Offer a very short reply. 0.33. What is the ratio of the Gross enrolment ratio (%) in Primary schools in Arab World to that in East Asia (all income levels)?
Keep it short and to the point. 0.81. What is the ratio of the Gross enrolment ratio (%) in Secondary schools in Arab World to that in East Asia (all income levels)?
Your answer should be compact. 0.98. What is the ratio of the Gross enrolment ratio (%) of Tertiary schools in Arab World to that in East Asia (all income levels)?
Offer a terse response. 1.14. What is the ratio of the Gross enrolment ratio (%) of Pre-primary schools in Arab World to that in East Asia (developing only)?
Give a very brief answer. 0.35. What is the ratio of the Gross enrolment ratio (%) in Primary schools in Arab World to that in East Asia (developing only)?
Your answer should be very brief. 0.81. What is the ratio of the Gross enrolment ratio (%) of Secondary schools in Arab World to that in East Asia (developing only)?
Offer a terse response. 1.04. What is the ratio of the Gross enrolment ratio (%) of Tertiary schools in Arab World to that in East Asia (developing only)?
Your answer should be very brief. 1.46. What is the ratio of the Gross enrolment ratio (%) in Pre-primary schools in Arab World to that in Euro area?
Your answer should be compact. 0.14. What is the ratio of the Gross enrolment ratio (%) in Primary schools in Arab World to that in Euro area?
Provide a succinct answer. 0.83. What is the ratio of the Gross enrolment ratio (%) in Secondary schools in Arab World to that in Euro area?
Ensure brevity in your answer.  0.56. What is the ratio of the Gross enrolment ratio (%) in Tertiary schools in Arab World to that in Euro area?
Offer a terse response. 0.3. What is the ratio of the Gross enrolment ratio (%) of Pre-primary schools in Caribbean small states to that in Central Europe?
Offer a very short reply. 1.17. What is the ratio of the Gross enrolment ratio (%) of Primary schools in Caribbean small states to that in Central Europe?
Provide a short and direct response. 1.01. What is the ratio of the Gross enrolment ratio (%) in Secondary schools in Caribbean small states to that in Central Europe?
Offer a terse response. 0.94. What is the ratio of the Gross enrolment ratio (%) of Tertiary schools in Caribbean small states to that in Central Europe?
Give a very brief answer. 0.38. What is the ratio of the Gross enrolment ratio (%) in Pre-primary schools in Caribbean small states to that in East Asia (all income levels)?
Your answer should be very brief. 1.81. What is the ratio of the Gross enrolment ratio (%) of Primary schools in Caribbean small states to that in East Asia (all income levels)?
Ensure brevity in your answer.  0.95. What is the ratio of the Gross enrolment ratio (%) in Secondary schools in Caribbean small states to that in East Asia (all income levels)?
Your answer should be very brief. 1.48. What is the ratio of the Gross enrolment ratio (%) of Tertiary schools in Caribbean small states to that in East Asia (all income levels)?
Give a very brief answer. 1.21. What is the ratio of the Gross enrolment ratio (%) in Pre-primary schools in Caribbean small states to that in East Asia (developing only)?
Your response must be concise. 1.95. What is the ratio of the Gross enrolment ratio (%) of Primary schools in Caribbean small states to that in East Asia (developing only)?
Your answer should be very brief. 0.95. What is the ratio of the Gross enrolment ratio (%) of Secondary schools in Caribbean small states to that in East Asia (developing only)?
Provide a short and direct response. 1.57. What is the ratio of the Gross enrolment ratio (%) of Tertiary schools in Caribbean small states to that in East Asia (developing only)?
Your answer should be compact. 1.56. What is the ratio of the Gross enrolment ratio (%) in Pre-primary schools in Caribbean small states to that in Euro area?
Offer a very short reply. 0.77. What is the ratio of the Gross enrolment ratio (%) of Primary schools in Caribbean small states to that in Euro area?
Provide a succinct answer. 0.97. What is the ratio of the Gross enrolment ratio (%) of Secondary schools in Caribbean small states to that in Euro area?
Offer a terse response. 0.85. What is the ratio of the Gross enrolment ratio (%) of Tertiary schools in Caribbean small states to that in Euro area?
Keep it short and to the point. 0.32. What is the ratio of the Gross enrolment ratio (%) of Pre-primary schools in Central Europe to that in East Asia (all income levels)?
Offer a terse response. 1.56. What is the ratio of the Gross enrolment ratio (%) of Primary schools in Central Europe to that in East Asia (all income levels)?
Provide a succinct answer. 0.94. What is the ratio of the Gross enrolment ratio (%) in Secondary schools in Central Europe to that in East Asia (all income levels)?
Provide a short and direct response. 1.57. What is the ratio of the Gross enrolment ratio (%) in Tertiary schools in Central Europe to that in East Asia (all income levels)?
Provide a succinct answer. 3.22. What is the ratio of the Gross enrolment ratio (%) in Pre-primary schools in Central Europe to that in East Asia (developing only)?
Keep it short and to the point. 1.67. What is the ratio of the Gross enrolment ratio (%) of Primary schools in Central Europe to that in East Asia (developing only)?
Provide a short and direct response. 0.94. What is the ratio of the Gross enrolment ratio (%) in Secondary schools in Central Europe to that in East Asia (developing only)?
Provide a short and direct response. 1.66. What is the ratio of the Gross enrolment ratio (%) in Tertiary schools in Central Europe to that in East Asia (developing only)?
Your answer should be very brief. 4.14. What is the ratio of the Gross enrolment ratio (%) of Pre-primary schools in Central Europe to that in Euro area?
Give a very brief answer. 0.66. What is the ratio of the Gross enrolment ratio (%) in Primary schools in Central Europe to that in Euro area?
Ensure brevity in your answer.  0.96. What is the ratio of the Gross enrolment ratio (%) of Secondary schools in Central Europe to that in Euro area?
Provide a short and direct response. 0.9. What is the ratio of the Gross enrolment ratio (%) of Tertiary schools in Central Europe to that in Euro area?
Offer a terse response. 0.86. What is the ratio of the Gross enrolment ratio (%) in Pre-primary schools in East Asia (all income levels) to that in East Asia (developing only)?
Offer a terse response. 1.07. What is the ratio of the Gross enrolment ratio (%) of Primary schools in East Asia (all income levels) to that in East Asia (developing only)?
Your answer should be compact. 1. What is the ratio of the Gross enrolment ratio (%) in Secondary schools in East Asia (all income levels) to that in East Asia (developing only)?
Offer a terse response. 1.06. What is the ratio of the Gross enrolment ratio (%) in Tertiary schools in East Asia (all income levels) to that in East Asia (developing only)?
Provide a short and direct response. 1.29. What is the ratio of the Gross enrolment ratio (%) in Pre-primary schools in East Asia (all income levels) to that in Euro area?
Provide a short and direct response. 0.42. What is the ratio of the Gross enrolment ratio (%) of Primary schools in East Asia (all income levels) to that in Euro area?
Give a very brief answer. 1.02. What is the ratio of the Gross enrolment ratio (%) in Secondary schools in East Asia (all income levels) to that in Euro area?
Offer a terse response. 0.57. What is the ratio of the Gross enrolment ratio (%) of Tertiary schools in East Asia (all income levels) to that in Euro area?
Your response must be concise. 0.27. What is the ratio of the Gross enrolment ratio (%) of Pre-primary schools in East Asia (developing only) to that in Euro area?
Provide a short and direct response. 0.39. What is the ratio of the Gross enrolment ratio (%) of Primary schools in East Asia (developing only) to that in Euro area?
Your answer should be very brief. 1.02. What is the ratio of the Gross enrolment ratio (%) of Secondary schools in East Asia (developing only) to that in Euro area?
Give a very brief answer. 0.54. What is the ratio of the Gross enrolment ratio (%) of Tertiary schools in East Asia (developing only) to that in Euro area?
Your answer should be very brief. 0.21. What is the difference between the highest and the second highest Gross enrolment ratio (%) in Pre-primary schools?
Provide a short and direct response. 22.55. What is the difference between the highest and the second highest Gross enrolment ratio (%) of Primary schools?
Provide a succinct answer. 0.35. What is the difference between the highest and the second highest Gross enrolment ratio (%) of Secondary schools?
Offer a terse response. 10.18. What is the difference between the highest and the second highest Gross enrolment ratio (%) of Tertiary schools?
Your response must be concise. 8.09. What is the difference between the highest and the lowest Gross enrolment ratio (%) in Pre-primary schools?
Ensure brevity in your answer.  83.67. What is the difference between the highest and the lowest Gross enrolment ratio (%) of Primary schools?
Make the answer very short. 19.84. What is the difference between the highest and the lowest Gross enrolment ratio (%) of Secondary schools?
Your answer should be compact. 47.37. What is the difference between the highest and the lowest Gross enrolment ratio (%) of Tertiary schools?
Ensure brevity in your answer.  45.66. 